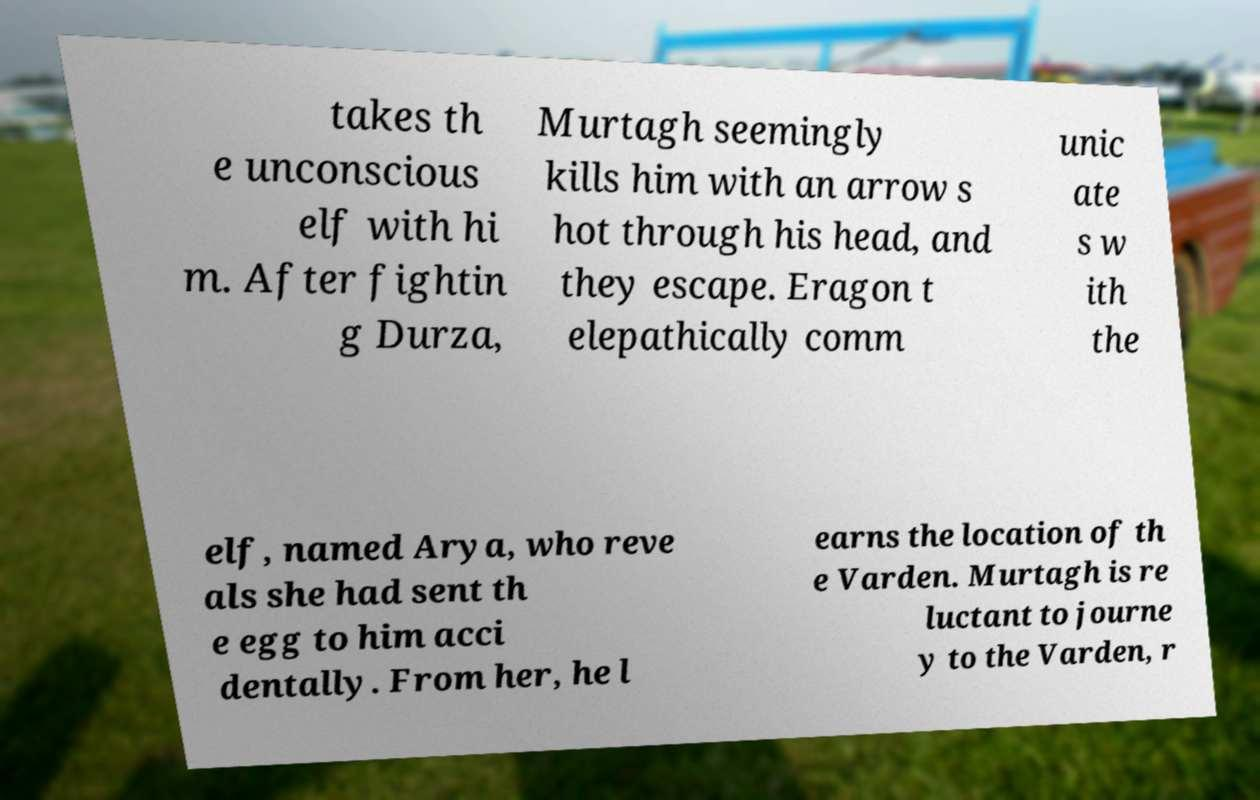Please identify and transcribe the text found in this image. takes th e unconscious elf with hi m. After fightin g Durza, Murtagh seemingly kills him with an arrow s hot through his head, and they escape. Eragon t elepathically comm unic ate s w ith the elf, named Arya, who reve als she had sent th e egg to him acci dentally. From her, he l earns the location of th e Varden. Murtagh is re luctant to journe y to the Varden, r 